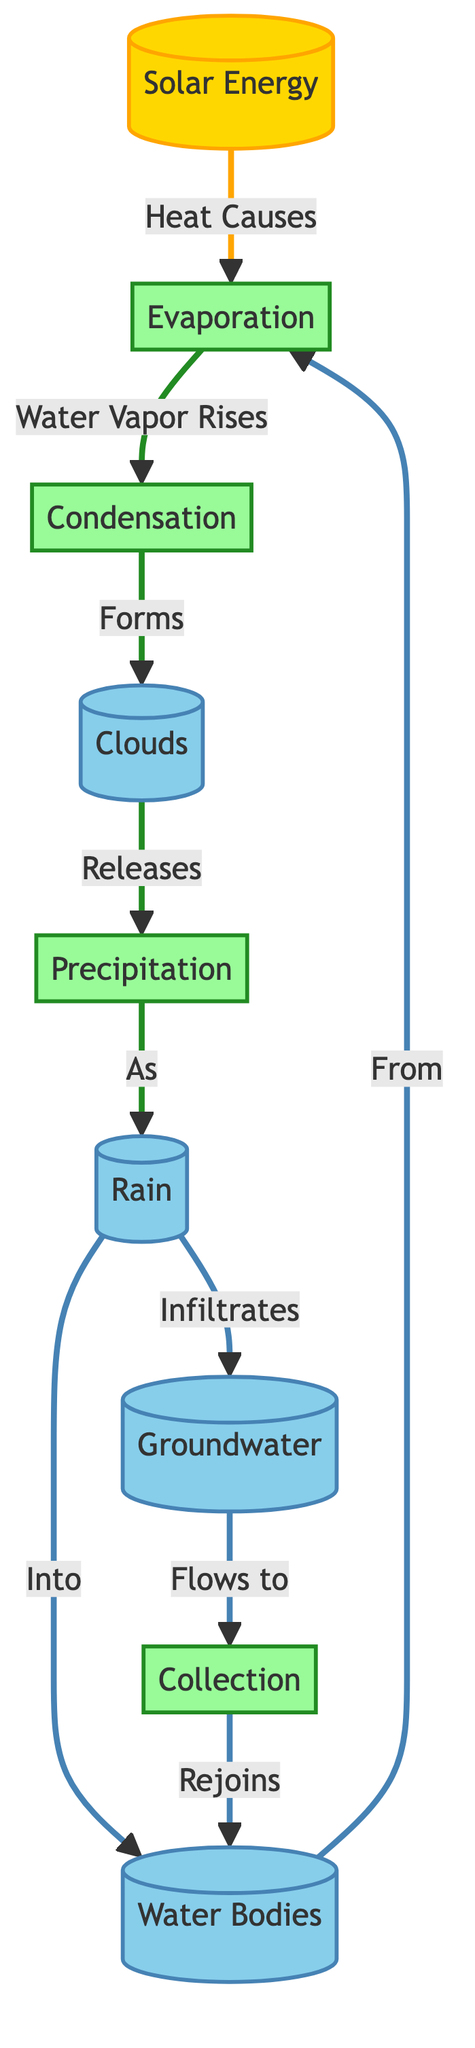What is the first process in the water cycle according to the diagram? The first process in the diagram is labeled as "Evaporation," which follows the interaction between "Solar Energy" and "Water Bodies." The arrows indicate that solar energy causes evaporation.
Answer: Evaporation How many processes are shown in the diagram? By counting the nodes in the diagram labeled as processes, we can identify five: "Evaporation," "Condensation," "Precipitation," "Collection," and "Infiltrates." Thus, there are a total of five process nodes.
Answer: Five What do clouds release as per the diagram? The diagram indicates that clouds release "Precipitation." This relationship is directly drawn from the clouds node to the precipitation node, confirming the flow of water back to the earth.
Answer: Precipitation Which element is affected by solar energy according to the diagram? The diagram shows that "Evaporation" is influenced by "Solar Energy," indicating that solar energy provides heat necessary for evaporation. Thus, water bodies are the elements impacted through the evaporation process.
Answer: Water Bodies What happens to rain after it falls, based on the diagram? The diagram shows two outcomes for rain: it either flows into "Water Bodies" or infiltrates "Groundwater." This illustrates how rainwater replenishes both surface water and underground water reserves.
Answer: Water Bodies and Groundwater What process occurs after evaporation and before condensation? The diagram illustrates a flow from "Evaporation" directly to "Condensation," indicating that condensation occurs as a subsequent step following evaporation.
Answer: Condensation How does groundwater interact with water bodies as depicted in the diagram? The diagram indicates that after groundwater absorbs water, it flows back to the "Collection" process, which in turn rejoins to the "Water Bodies." Hence, groundwater is an essential part of replenishing surface water bodies.
Answer: Flows to Collection Which process directly leads to cloud formation? "Condensation" is the process that directly leads to cloud formation, as shown in the diagram where water vapor rising from evaporation forms clouds through condensation.
Answer: Condensation How many nodes are classified as water elements in the diagram? The diagram reveals three nodes identified with water: "Water Bodies," "Clouds," and "Groundwater." By counting them, we find there are a total of three water-related nodes.
Answer: Three 